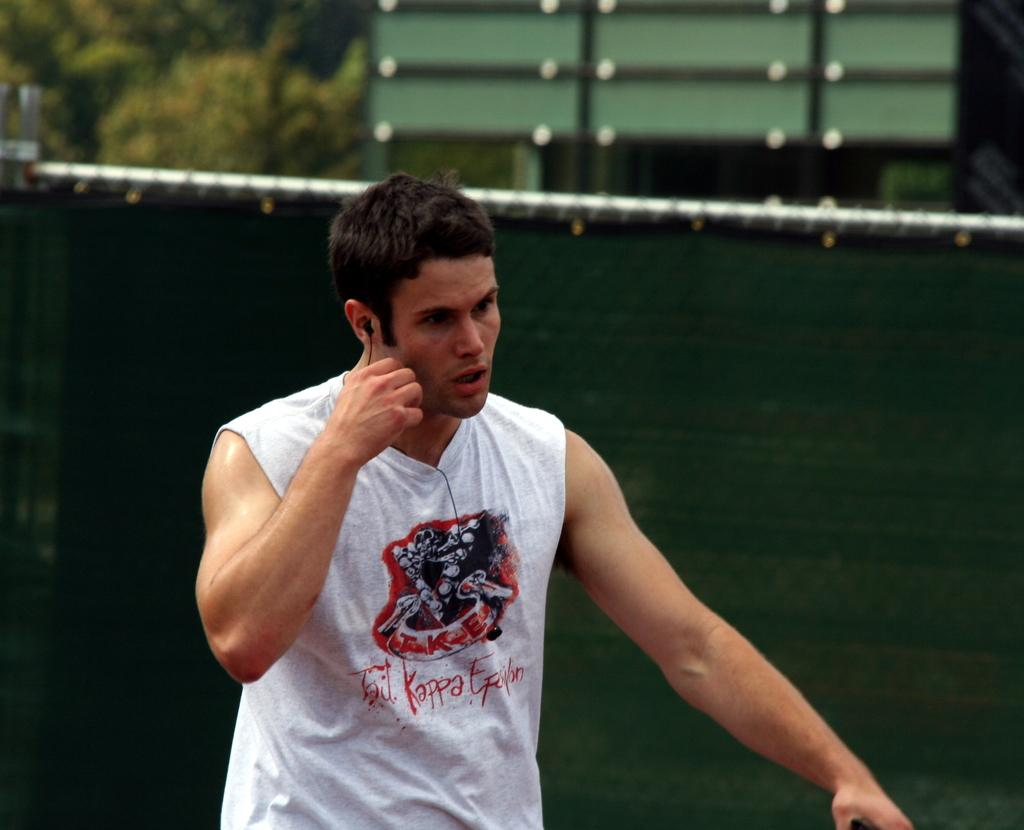Provide a one-sentence caption for the provided image. A man wearing a shirt that says Tri Kappa Epillon walks in front of a green fence. 